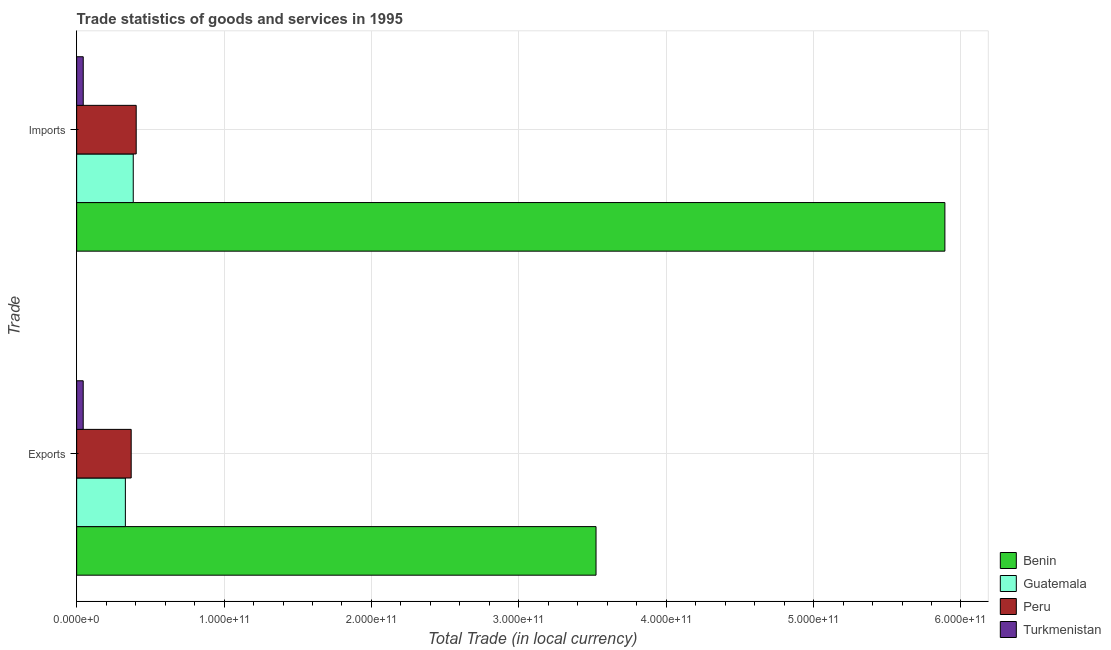How many bars are there on the 2nd tick from the top?
Your answer should be very brief. 4. What is the label of the 2nd group of bars from the top?
Provide a succinct answer. Exports. What is the imports of goods and services in Benin?
Ensure brevity in your answer.  5.89e+11. Across all countries, what is the maximum imports of goods and services?
Offer a terse response. 5.89e+11. Across all countries, what is the minimum export of goods and services?
Your answer should be compact. 4.44e+09. In which country was the export of goods and services maximum?
Your answer should be compact. Benin. In which country was the imports of goods and services minimum?
Offer a terse response. Turkmenistan. What is the total imports of goods and services in the graph?
Your answer should be very brief. 6.72e+11. What is the difference between the imports of goods and services in Benin and that in Guatemala?
Make the answer very short. 5.51e+11. What is the difference between the imports of goods and services in Benin and the export of goods and services in Turkmenistan?
Provide a short and direct response. 5.85e+11. What is the average export of goods and services per country?
Provide a succinct answer. 1.07e+11. What is the difference between the imports of goods and services and export of goods and services in Turkmenistan?
Make the answer very short. 1.24e+07. What is the ratio of the imports of goods and services in Peru to that in Guatemala?
Your answer should be very brief. 1.05. Is the export of goods and services in Benin less than that in Guatemala?
Provide a short and direct response. No. In how many countries, is the imports of goods and services greater than the average imports of goods and services taken over all countries?
Provide a succinct answer. 1. What does the 1st bar from the top in Exports represents?
Give a very brief answer. Turkmenistan. What does the 1st bar from the bottom in Exports represents?
Ensure brevity in your answer.  Benin. How many bars are there?
Provide a succinct answer. 8. Are all the bars in the graph horizontal?
Offer a very short reply. Yes. What is the difference between two consecutive major ticks on the X-axis?
Offer a terse response. 1.00e+11. Are the values on the major ticks of X-axis written in scientific E-notation?
Your answer should be compact. Yes. Where does the legend appear in the graph?
Ensure brevity in your answer.  Bottom right. How are the legend labels stacked?
Provide a short and direct response. Vertical. What is the title of the graph?
Your answer should be compact. Trade statistics of goods and services in 1995. What is the label or title of the X-axis?
Keep it short and to the point. Total Trade (in local currency). What is the label or title of the Y-axis?
Provide a succinct answer. Trade. What is the Total Trade (in local currency) of Benin in Exports?
Your response must be concise. 3.52e+11. What is the Total Trade (in local currency) in Guatemala in Exports?
Keep it short and to the point. 3.31e+1. What is the Total Trade (in local currency) in Peru in Exports?
Your answer should be compact. 3.70e+1. What is the Total Trade (in local currency) in Turkmenistan in Exports?
Offer a very short reply. 4.44e+09. What is the Total Trade (in local currency) of Benin in Imports?
Ensure brevity in your answer.  5.89e+11. What is the Total Trade (in local currency) in Guatemala in Imports?
Give a very brief answer. 3.84e+1. What is the Total Trade (in local currency) in Peru in Imports?
Keep it short and to the point. 4.04e+1. What is the Total Trade (in local currency) of Turkmenistan in Imports?
Your answer should be compact. 4.46e+09. Across all Trade, what is the maximum Total Trade (in local currency) in Benin?
Your answer should be very brief. 5.89e+11. Across all Trade, what is the maximum Total Trade (in local currency) of Guatemala?
Give a very brief answer. 3.84e+1. Across all Trade, what is the maximum Total Trade (in local currency) in Peru?
Offer a very short reply. 4.04e+1. Across all Trade, what is the maximum Total Trade (in local currency) in Turkmenistan?
Your answer should be very brief. 4.46e+09. Across all Trade, what is the minimum Total Trade (in local currency) of Benin?
Your answer should be very brief. 3.52e+11. Across all Trade, what is the minimum Total Trade (in local currency) of Guatemala?
Give a very brief answer. 3.31e+1. Across all Trade, what is the minimum Total Trade (in local currency) of Peru?
Provide a short and direct response. 3.70e+1. Across all Trade, what is the minimum Total Trade (in local currency) in Turkmenistan?
Your answer should be very brief. 4.44e+09. What is the total Total Trade (in local currency) of Benin in the graph?
Ensure brevity in your answer.  9.41e+11. What is the total Total Trade (in local currency) in Guatemala in the graph?
Your answer should be compact. 7.15e+1. What is the total Total Trade (in local currency) of Peru in the graph?
Provide a short and direct response. 7.74e+1. What is the total Total Trade (in local currency) in Turkmenistan in the graph?
Your answer should be very brief. 8.90e+09. What is the difference between the Total Trade (in local currency) in Benin in Exports and that in Imports?
Provide a short and direct response. -2.37e+11. What is the difference between the Total Trade (in local currency) of Guatemala in Exports and that in Imports?
Provide a short and direct response. -5.35e+09. What is the difference between the Total Trade (in local currency) of Peru in Exports and that in Imports?
Your response must be concise. -3.40e+09. What is the difference between the Total Trade (in local currency) in Turkmenistan in Exports and that in Imports?
Make the answer very short. -1.24e+07. What is the difference between the Total Trade (in local currency) of Benin in Exports and the Total Trade (in local currency) of Guatemala in Imports?
Provide a succinct answer. 3.14e+11. What is the difference between the Total Trade (in local currency) in Benin in Exports and the Total Trade (in local currency) in Peru in Imports?
Provide a short and direct response. 3.12e+11. What is the difference between the Total Trade (in local currency) in Benin in Exports and the Total Trade (in local currency) in Turkmenistan in Imports?
Ensure brevity in your answer.  3.48e+11. What is the difference between the Total Trade (in local currency) of Guatemala in Exports and the Total Trade (in local currency) of Peru in Imports?
Your answer should be compact. -7.34e+09. What is the difference between the Total Trade (in local currency) of Guatemala in Exports and the Total Trade (in local currency) of Turkmenistan in Imports?
Give a very brief answer. 2.86e+1. What is the difference between the Total Trade (in local currency) of Peru in Exports and the Total Trade (in local currency) of Turkmenistan in Imports?
Your answer should be compact. 3.25e+1. What is the average Total Trade (in local currency) in Benin per Trade?
Your response must be concise. 4.71e+11. What is the average Total Trade (in local currency) of Guatemala per Trade?
Offer a terse response. 3.57e+1. What is the average Total Trade (in local currency) in Peru per Trade?
Keep it short and to the point. 3.87e+1. What is the average Total Trade (in local currency) of Turkmenistan per Trade?
Ensure brevity in your answer.  4.45e+09. What is the difference between the Total Trade (in local currency) of Benin and Total Trade (in local currency) of Guatemala in Exports?
Offer a terse response. 3.19e+11. What is the difference between the Total Trade (in local currency) of Benin and Total Trade (in local currency) of Peru in Exports?
Give a very brief answer. 3.15e+11. What is the difference between the Total Trade (in local currency) in Benin and Total Trade (in local currency) in Turkmenistan in Exports?
Give a very brief answer. 3.48e+11. What is the difference between the Total Trade (in local currency) of Guatemala and Total Trade (in local currency) of Peru in Exports?
Your answer should be very brief. -3.95e+09. What is the difference between the Total Trade (in local currency) of Guatemala and Total Trade (in local currency) of Turkmenistan in Exports?
Give a very brief answer. 2.86e+1. What is the difference between the Total Trade (in local currency) of Peru and Total Trade (in local currency) of Turkmenistan in Exports?
Your response must be concise. 3.26e+1. What is the difference between the Total Trade (in local currency) in Benin and Total Trade (in local currency) in Guatemala in Imports?
Keep it short and to the point. 5.51e+11. What is the difference between the Total Trade (in local currency) of Benin and Total Trade (in local currency) of Peru in Imports?
Provide a short and direct response. 5.49e+11. What is the difference between the Total Trade (in local currency) of Benin and Total Trade (in local currency) of Turkmenistan in Imports?
Your answer should be very brief. 5.85e+11. What is the difference between the Total Trade (in local currency) of Guatemala and Total Trade (in local currency) of Peru in Imports?
Your answer should be very brief. -2.00e+09. What is the difference between the Total Trade (in local currency) of Guatemala and Total Trade (in local currency) of Turkmenistan in Imports?
Make the answer very short. 3.39e+1. What is the difference between the Total Trade (in local currency) of Peru and Total Trade (in local currency) of Turkmenistan in Imports?
Give a very brief answer. 3.59e+1. What is the ratio of the Total Trade (in local currency) in Benin in Exports to that in Imports?
Make the answer very short. 0.6. What is the ratio of the Total Trade (in local currency) of Guatemala in Exports to that in Imports?
Provide a succinct answer. 0.86. What is the ratio of the Total Trade (in local currency) of Peru in Exports to that in Imports?
Offer a terse response. 0.92. What is the ratio of the Total Trade (in local currency) in Turkmenistan in Exports to that in Imports?
Your answer should be very brief. 1. What is the difference between the highest and the second highest Total Trade (in local currency) in Benin?
Give a very brief answer. 2.37e+11. What is the difference between the highest and the second highest Total Trade (in local currency) in Guatemala?
Keep it short and to the point. 5.35e+09. What is the difference between the highest and the second highest Total Trade (in local currency) in Peru?
Give a very brief answer. 3.40e+09. What is the difference between the highest and the second highest Total Trade (in local currency) of Turkmenistan?
Give a very brief answer. 1.24e+07. What is the difference between the highest and the lowest Total Trade (in local currency) of Benin?
Your answer should be very brief. 2.37e+11. What is the difference between the highest and the lowest Total Trade (in local currency) in Guatemala?
Offer a terse response. 5.35e+09. What is the difference between the highest and the lowest Total Trade (in local currency) of Peru?
Ensure brevity in your answer.  3.40e+09. What is the difference between the highest and the lowest Total Trade (in local currency) of Turkmenistan?
Offer a very short reply. 1.24e+07. 